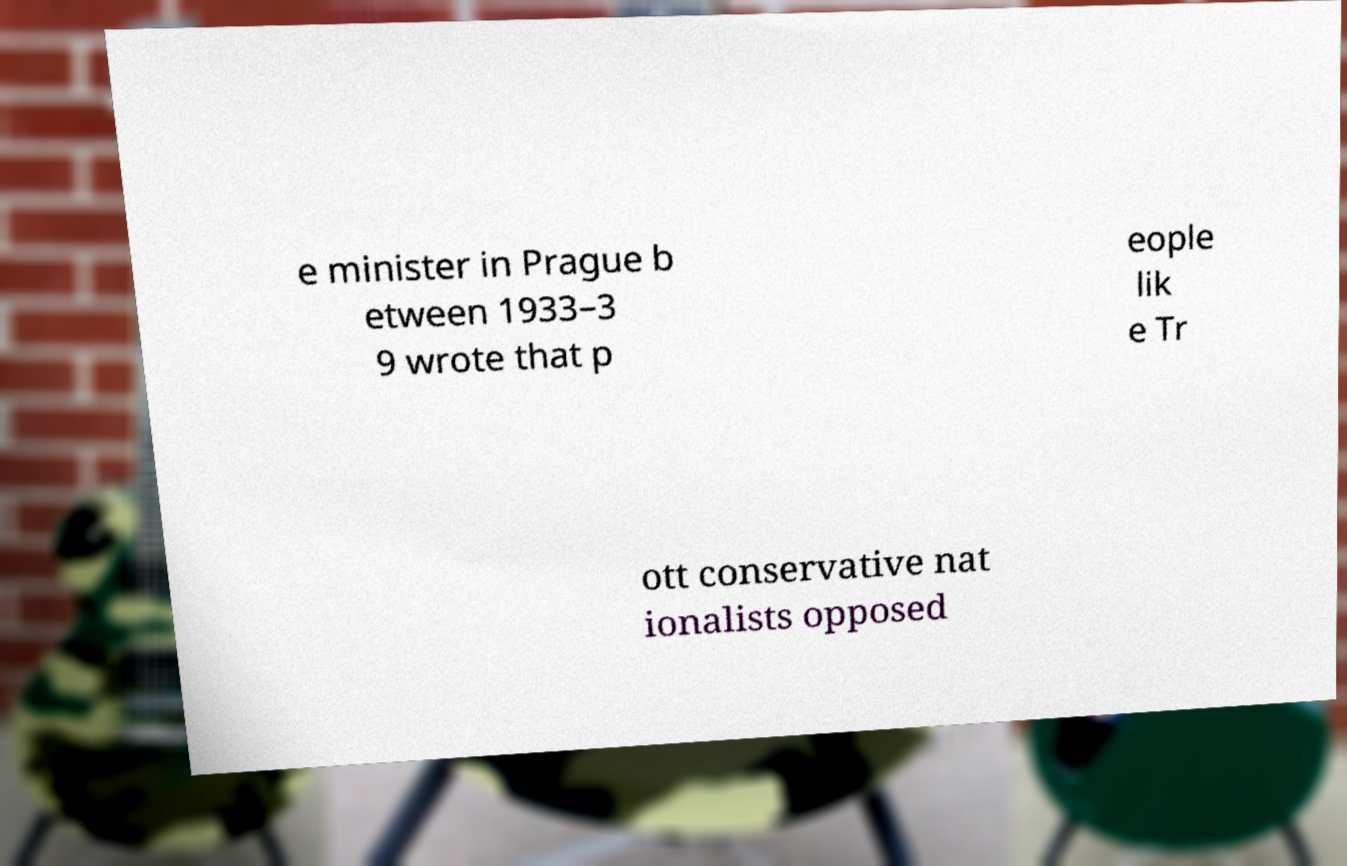Could you assist in decoding the text presented in this image and type it out clearly? e minister in Prague b etween 1933–3 9 wrote that p eople lik e Tr ott conservative nat ionalists opposed 